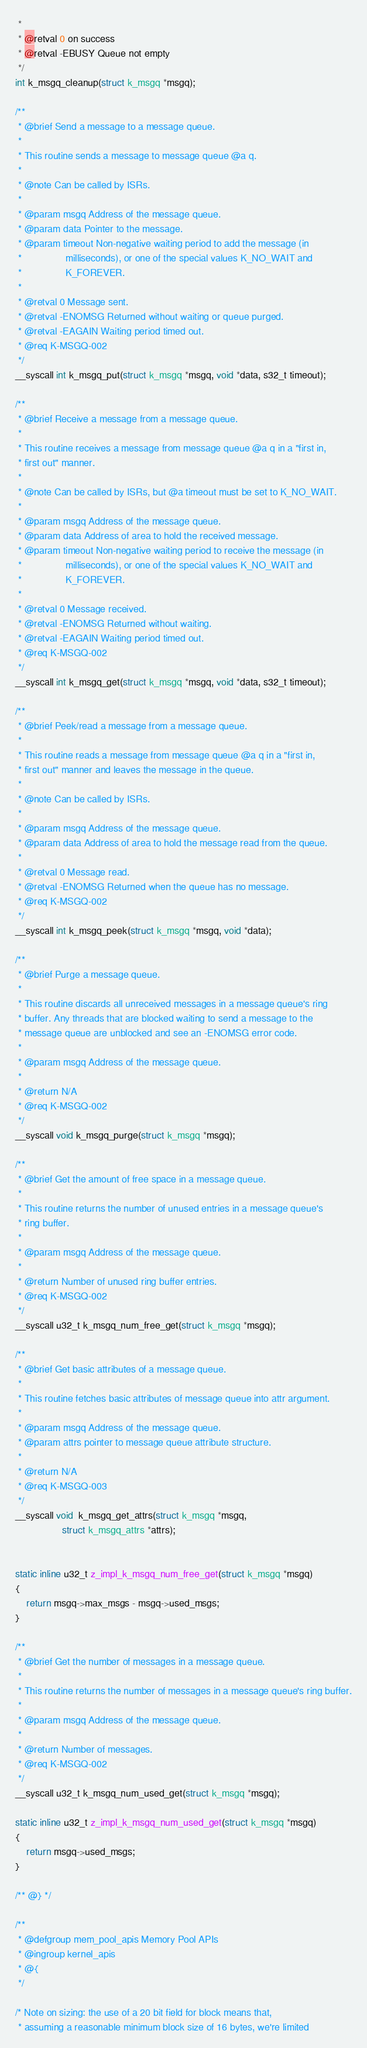Convert code to text. <code><loc_0><loc_0><loc_500><loc_500><_C_> *
 * @retval 0 on success
 * @retval -EBUSY Queue not empty
 */
int k_msgq_cleanup(struct k_msgq *msgq);

/**
 * @brief Send a message to a message queue.
 *
 * This routine sends a message to message queue @a q.
 *
 * @note Can be called by ISRs.
 *
 * @param msgq Address of the message queue.
 * @param data Pointer to the message.
 * @param timeout Non-negative waiting period to add the message (in
 *                milliseconds), or one of the special values K_NO_WAIT and
 *                K_FOREVER.
 *
 * @retval 0 Message sent.
 * @retval -ENOMSG Returned without waiting or queue purged.
 * @retval -EAGAIN Waiting period timed out.
 * @req K-MSGQ-002
 */
__syscall int k_msgq_put(struct k_msgq *msgq, void *data, s32_t timeout);

/**
 * @brief Receive a message from a message queue.
 *
 * This routine receives a message from message queue @a q in a "first in,
 * first out" manner.
 *
 * @note Can be called by ISRs, but @a timeout must be set to K_NO_WAIT.
 *
 * @param msgq Address of the message queue.
 * @param data Address of area to hold the received message.
 * @param timeout Non-negative waiting period to receive the message (in
 *                milliseconds), or one of the special values K_NO_WAIT and
 *                K_FOREVER.
 *
 * @retval 0 Message received.
 * @retval -ENOMSG Returned without waiting.
 * @retval -EAGAIN Waiting period timed out.
 * @req K-MSGQ-002
 */
__syscall int k_msgq_get(struct k_msgq *msgq, void *data, s32_t timeout);

/**
 * @brief Peek/read a message from a message queue.
 *
 * This routine reads a message from message queue @a q in a "first in,
 * first out" manner and leaves the message in the queue.
 *
 * @note Can be called by ISRs.
 *
 * @param msgq Address of the message queue.
 * @param data Address of area to hold the message read from the queue.
 *
 * @retval 0 Message read.
 * @retval -ENOMSG Returned when the queue has no message.
 * @req K-MSGQ-002
 */
__syscall int k_msgq_peek(struct k_msgq *msgq, void *data);

/**
 * @brief Purge a message queue.
 *
 * This routine discards all unreceived messages in a message queue's ring
 * buffer. Any threads that are blocked waiting to send a message to the
 * message queue are unblocked and see an -ENOMSG error code.
 *
 * @param msgq Address of the message queue.
 *
 * @return N/A
 * @req K-MSGQ-002
 */
__syscall void k_msgq_purge(struct k_msgq *msgq);

/**
 * @brief Get the amount of free space in a message queue.
 *
 * This routine returns the number of unused entries in a message queue's
 * ring buffer.
 *
 * @param msgq Address of the message queue.
 *
 * @return Number of unused ring buffer entries.
 * @req K-MSGQ-002
 */
__syscall u32_t k_msgq_num_free_get(struct k_msgq *msgq);

/**
 * @brief Get basic attributes of a message queue.
 *
 * This routine fetches basic attributes of message queue into attr argument.
 *
 * @param msgq Address of the message queue.
 * @param attrs pointer to message queue attribute structure.
 *
 * @return N/A
 * @req K-MSGQ-003
 */
__syscall void  k_msgq_get_attrs(struct k_msgq *msgq,
				 struct k_msgq_attrs *attrs);


static inline u32_t z_impl_k_msgq_num_free_get(struct k_msgq *msgq)
{
	return msgq->max_msgs - msgq->used_msgs;
}

/**
 * @brief Get the number of messages in a message queue.
 *
 * This routine returns the number of messages in a message queue's ring buffer.
 *
 * @param msgq Address of the message queue.
 *
 * @return Number of messages.
 * @req K-MSGQ-002
 */
__syscall u32_t k_msgq_num_used_get(struct k_msgq *msgq);

static inline u32_t z_impl_k_msgq_num_used_get(struct k_msgq *msgq)
{
	return msgq->used_msgs;
}

/** @} */

/**
 * @defgroup mem_pool_apis Memory Pool APIs
 * @ingroup kernel_apis
 * @{
 */

/* Note on sizing: the use of a 20 bit field for block means that,
 * assuming a reasonable minimum block size of 16 bytes, we're limited</code> 